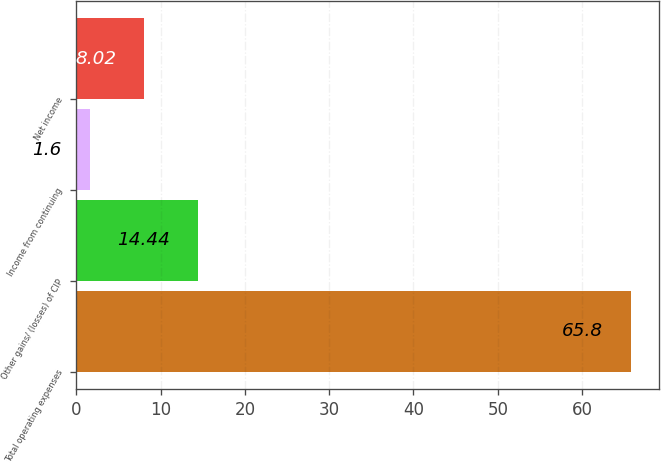Convert chart. <chart><loc_0><loc_0><loc_500><loc_500><bar_chart><fcel>Total operating expenses<fcel>Other gains/ (losses) of CIP<fcel>Income from continuing<fcel>Net income<nl><fcel>65.8<fcel>14.44<fcel>1.6<fcel>8.02<nl></chart> 